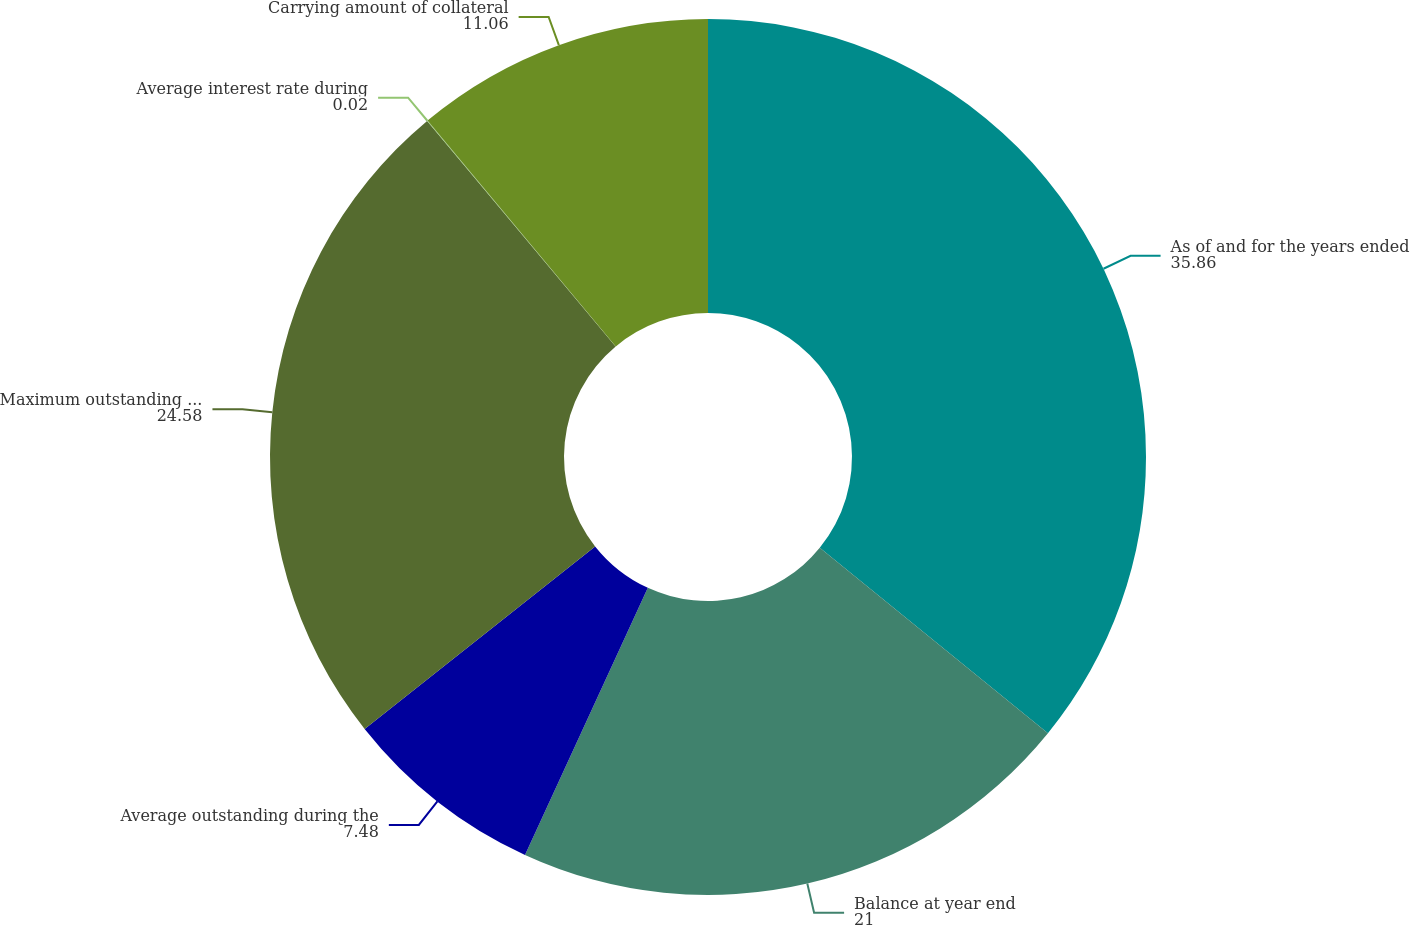Convert chart to OTSL. <chart><loc_0><loc_0><loc_500><loc_500><pie_chart><fcel>As of and for the years ended<fcel>Balance at year end<fcel>Average outstanding during the<fcel>Maximum outstanding at any<fcel>Average interest rate during<fcel>Carrying amount of collateral<nl><fcel>35.86%<fcel>21.0%<fcel>7.48%<fcel>24.58%<fcel>0.02%<fcel>11.06%<nl></chart> 